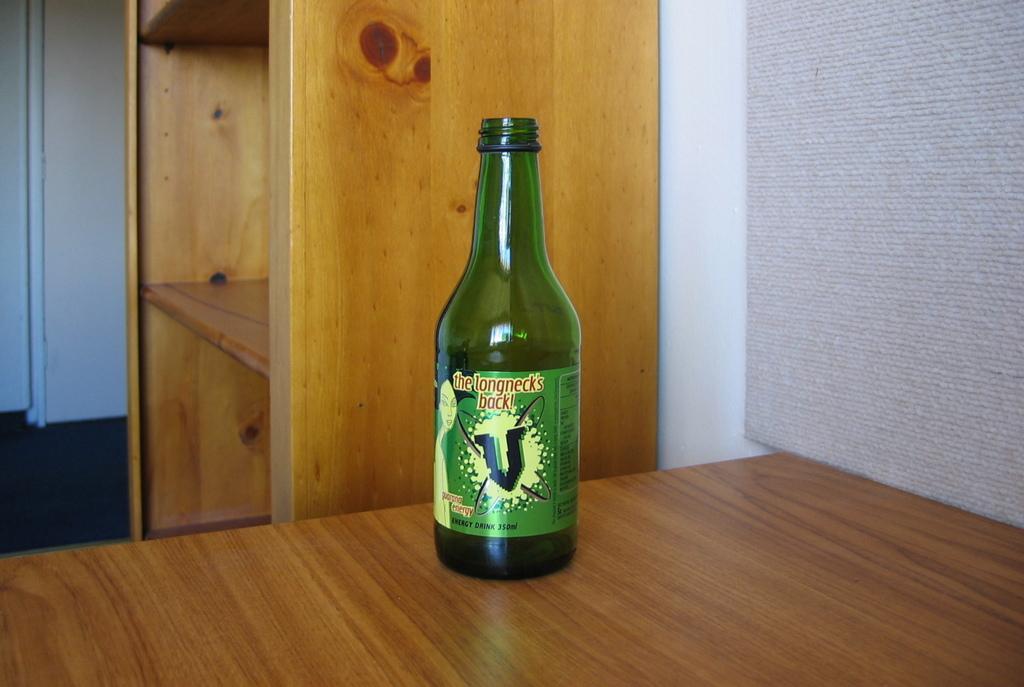How would you summarize this image in a sentence or two? In this picture there is a green bottle placed on the table. The long necks back is written on it and a symbol of V is named on it. There is a shelf in the background which is empty. Both the shelf and the table is brown in colour 